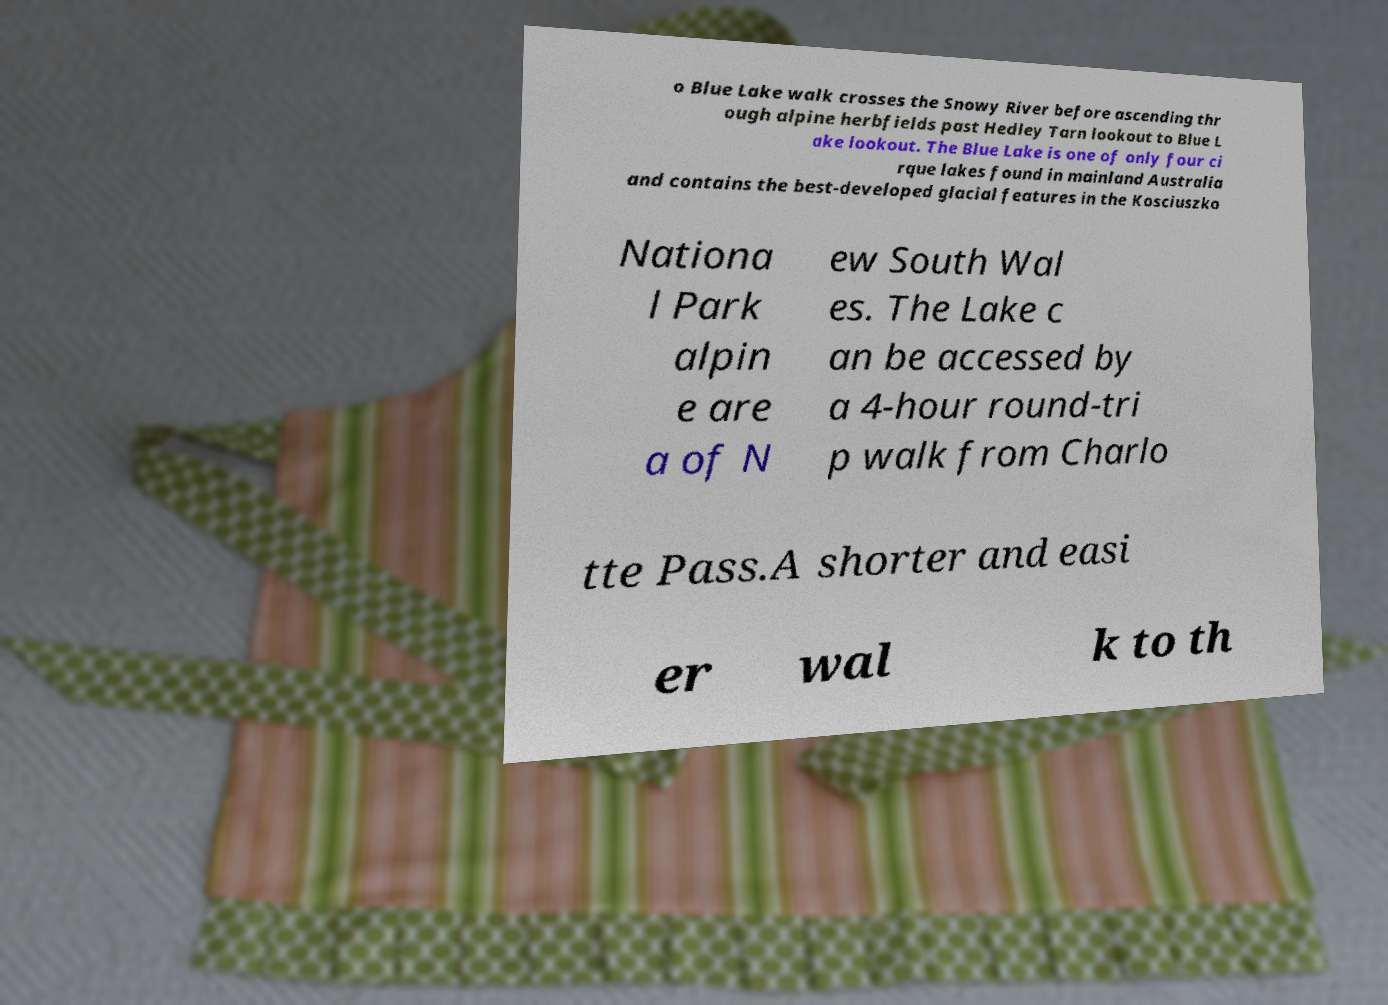I need the written content from this picture converted into text. Can you do that? o Blue Lake walk crosses the Snowy River before ascending thr ough alpine herbfields past Hedley Tarn lookout to Blue L ake lookout. The Blue Lake is one of only four ci rque lakes found in mainland Australia and contains the best-developed glacial features in the Kosciuszko Nationa l Park alpin e are a of N ew South Wal es. The Lake c an be accessed by a 4-hour round-tri p walk from Charlo tte Pass.A shorter and easi er wal k to th 